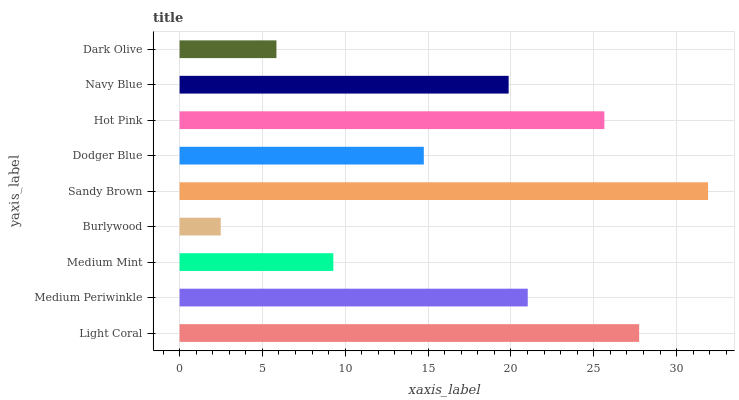Is Burlywood the minimum?
Answer yes or no. Yes. Is Sandy Brown the maximum?
Answer yes or no. Yes. Is Medium Periwinkle the minimum?
Answer yes or no. No. Is Medium Periwinkle the maximum?
Answer yes or no. No. Is Light Coral greater than Medium Periwinkle?
Answer yes or no. Yes. Is Medium Periwinkle less than Light Coral?
Answer yes or no. Yes. Is Medium Periwinkle greater than Light Coral?
Answer yes or no. No. Is Light Coral less than Medium Periwinkle?
Answer yes or no. No. Is Navy Blue the high median?
Answer yes or no. Yes. Is Navy Blue the low median?
Answer yes or no. Yes. Is Hot Pink the high median?
Answer yes or no. No. Is Light Coral the low median?
Answer yes or no. No. 